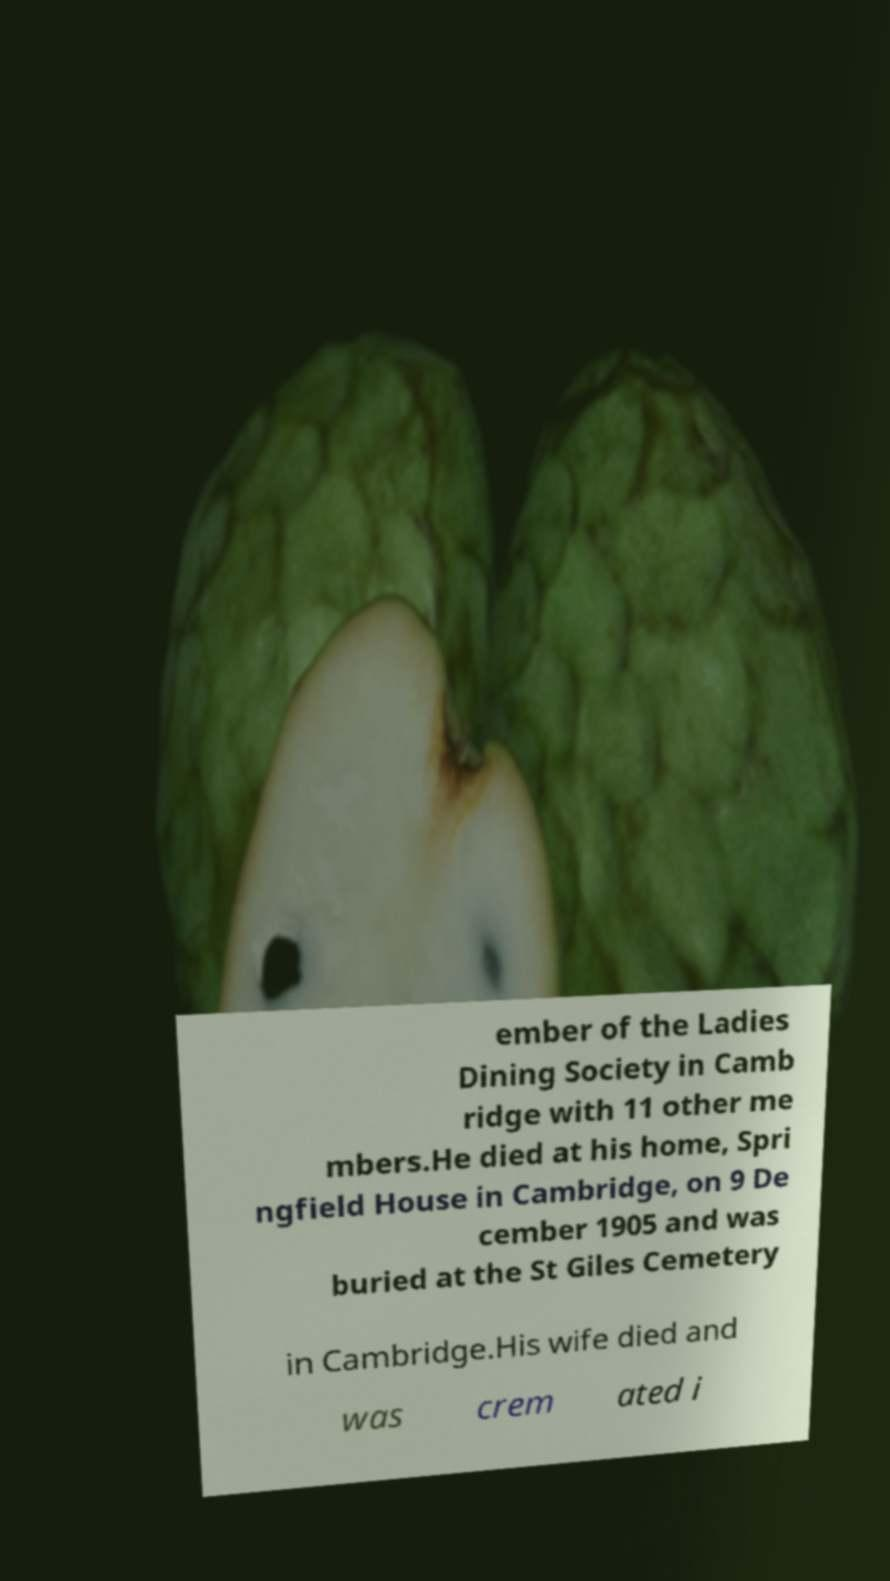Can you accurately transcribe the text from the provided image for me? ember of the Ladies Dining Society in Camb ridge with 11 other me mbers.He died at his home, Spri ngfield House in Cambridge, on 9 De cember 1905 and was buried at the St Giles Cemetery in Cambridge.His wife died and was crem ated i 